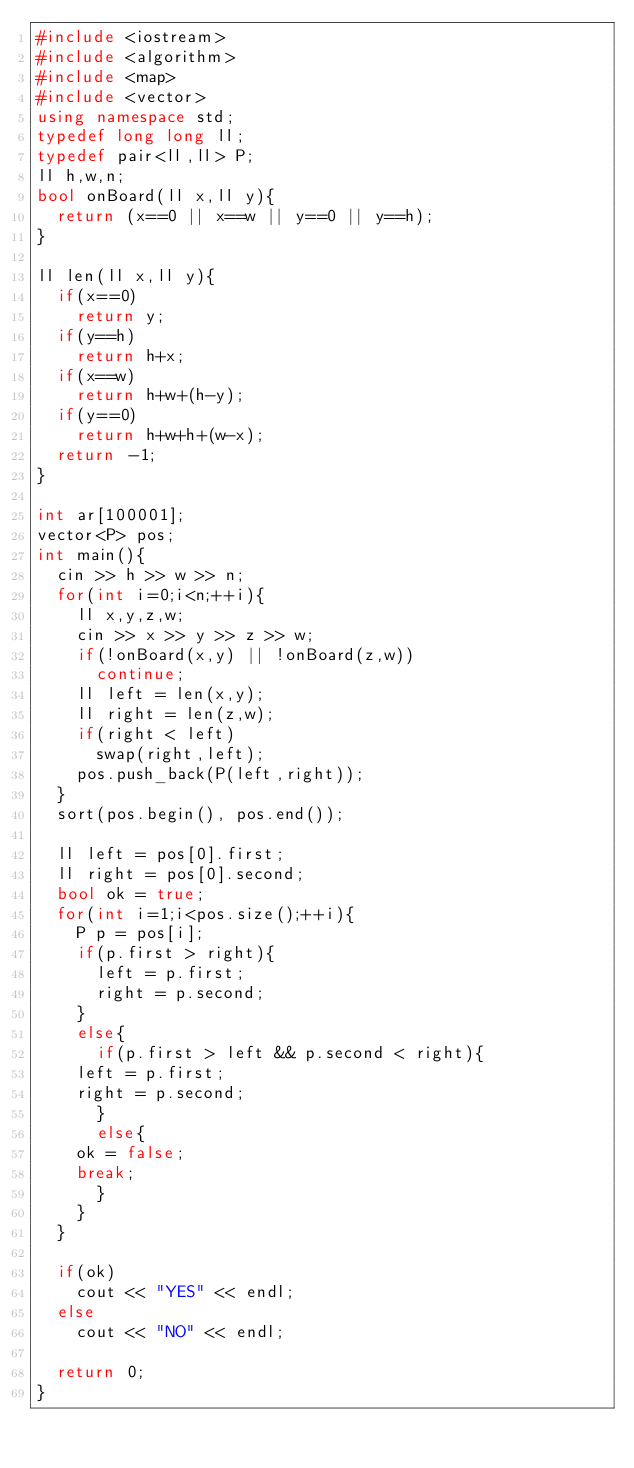<code> <loc_0><loc_0><loc_500><loc_500><_C++_>#include <iostream>
#include <algorithm>
#include <map>
#include <vector>
using namespace std;
typedef long long ll;
typedef pair<ll,ll> P;
ll h,w,n;
bool onBoard(ll x,ll y){
  return (x==0 || x==w || y==0 || y==h);
}

ll len(ll x,ll y){
  if(x==0)
    return y;
  if(y==h)
    return h+x;
  if(x==w)
    return h+w+(h-y);
  if(y==0)
    return h+w+h+(w-x);
  return -1;
}

int ar[100001];
vector<P> pos;
int main(){
  cin >> h >> w >> n;
  for(int i=0;i<n;++i){
    ll x,y,z,w;
    cin >> x >> y >> z >> w;
    if(!onBoard(x,y) || !onBoard(z,w))
      continue;
    ll left = len(x,y);
    ll right = len(z,w);
    if(right < left)
      swap(right,left);
    pos.push_back(P(left,right));
  }
  sort(pos.begin(), pos.end());

  ll left = pos[0].first;
  ll right = pos[0].second;
  bool ok = true;
  for(int i=1;i<pos.size();++i){
    P p = pos[i];
    if(p.first > right){
      left = p.first;
      right = p.second;
    }
    else{
      if(p.first > left && p.second < right){
	left = p.first;
	right = p.second;
      }
      else{
	ok = false;
	break;
      }
    }
  }

  if(ok)
    cout << "YES" << endl;
  else
    cout << "NO" << endl;
 
  return 0;
}
</code> 